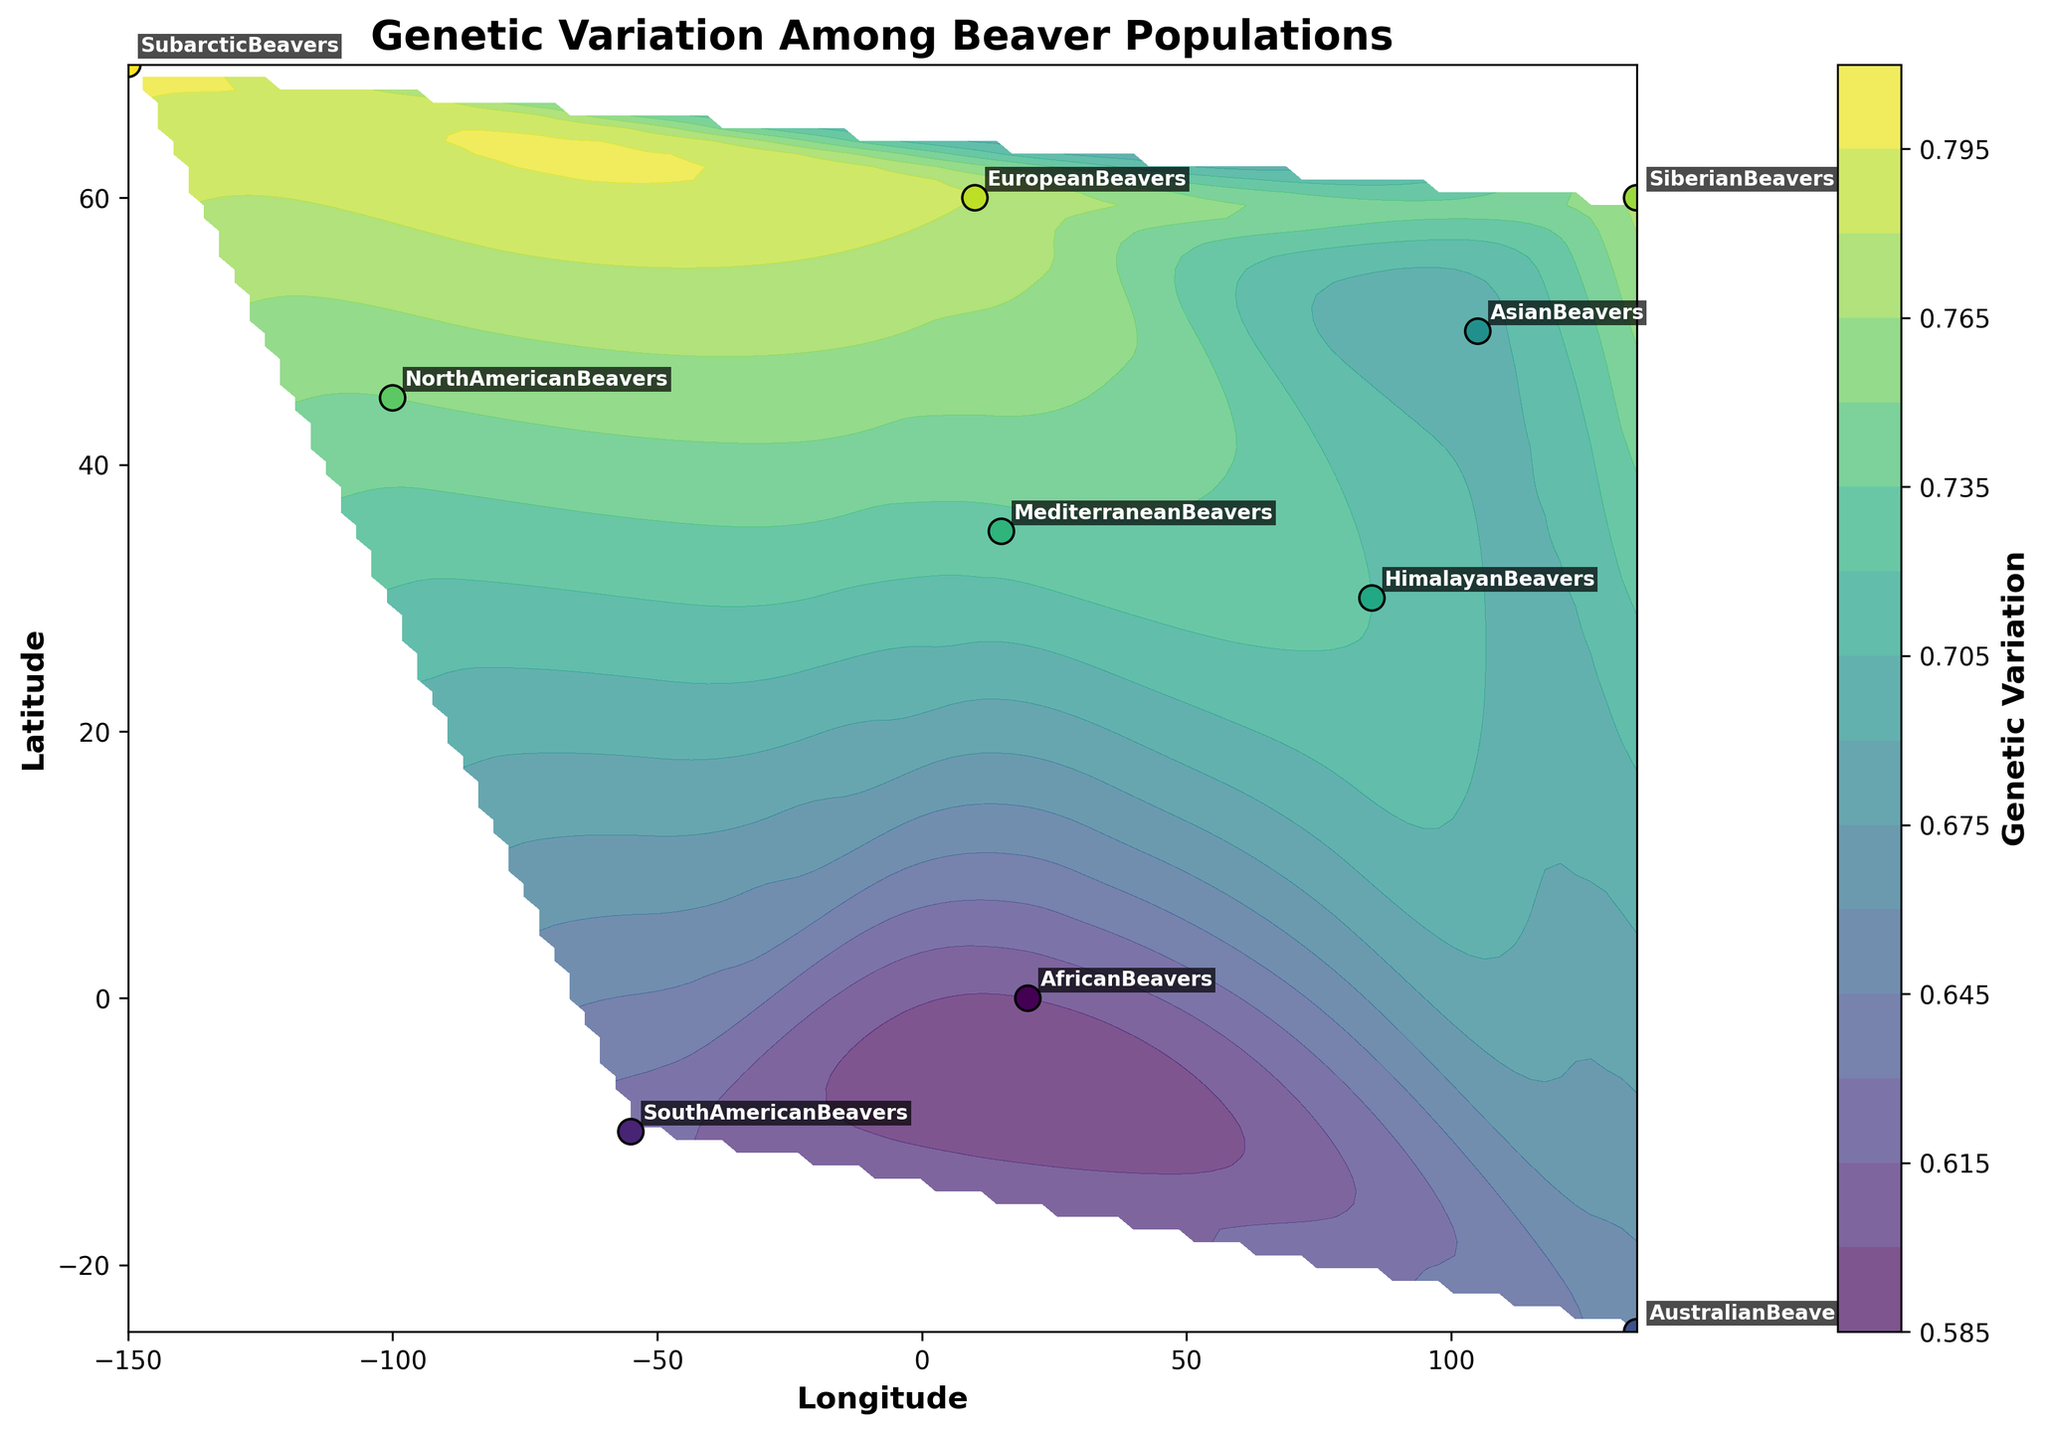What's the title of the plot? The title of the plot is usually positioned at the top of the figure and provides a summary of what the plot is about. In this case, the title is "Genetic Variation Among Beaver Populations," clearly visible at the top center of the plot.
Answer: Genetic Variation Among Beaver Populations What do the color gradients represent in this figure? The color gradients in the contour plot represent the levels of Genetic Variation across different geographic locations. This can be inferred from the color bar on the right side of the plot, which indicates the range of Genetic Variation values associated with different shades/colors.
Answer: Levels of Genetic Variation Which population is located at approximately (70, -150) degrees latitude and longitude? The population labels are annotated near the data points. By locating the point at (70, -150) degrees on the plot and checking the label, we can see that the "SubarcticBeavers" population is located at this coordinate.
Answer: SubarcticBeavers Between North American Beavers and European Beavers, which population shows higher genetic variation? By comparing the color intensity and checking the exact values near these populations in the plot, we can see that the North American Beavers have a genetic variation of 0.75 while European Beavers have 0.78. Therefore, European Beavers show higher genetic variation.
Answer: European Beavers What is the range of Longitude displayed in this plot? The range of Longitude can be observed by looking at the x-axis labels. The minimum longitude shown is approximately -150 degrees and the maximum is around 135 degrees.
Answer: -150 to 135 degrees How many total data points are plotted in this figure? The number of data points can be quickly inferred by counting the labeled population names. Each label corresponds to a data point, and there are 10 population labels, thus 10 data points.
Answer: 10 Identify the population with the lowest genetic variation and state its value. By observing the contour colors and cross-referencing with the color bar, we notice the darkest color near the zero latitude line. Checking the labels, "AfricanBeavers" have the lowest genetic variation of 0.60.
Answer: AfricanBeavers, 0.60 Which populations have genetic variation greater than 0.70 but less than 0.75? By inspecting the contour plot colors and population values, we identify that NorthAmericanBeavers (0.75), MediterraneanBeavers (0.73), and HimalayanBeavers (0.72) fall within this range.
Answer: MediterraneanBeavers, HimalayanBeavers What are the latitudes of populations with genetic variation higher than 0.75? From the plot, the populations with genetic variation greater than 0.75 are EuropeanBeavers (0.78) and SubarcticBeavers (0.80). Their latitudes are 60.0 and 70.0 degrees respectively.
Answer: 60.0, 70.0 degrees Which population is geographically nearest to the origin (0,0) coordinates, and how does its genetic variation compare to others? Checking the population annotations, “AfricanBeavers” is closest to the origin at coordinates (0, 20). The genetic variation for African Beavers is 0.60, the lowest among the populations observed in the plot.
Answer: AfricanBeavers, 0.60 